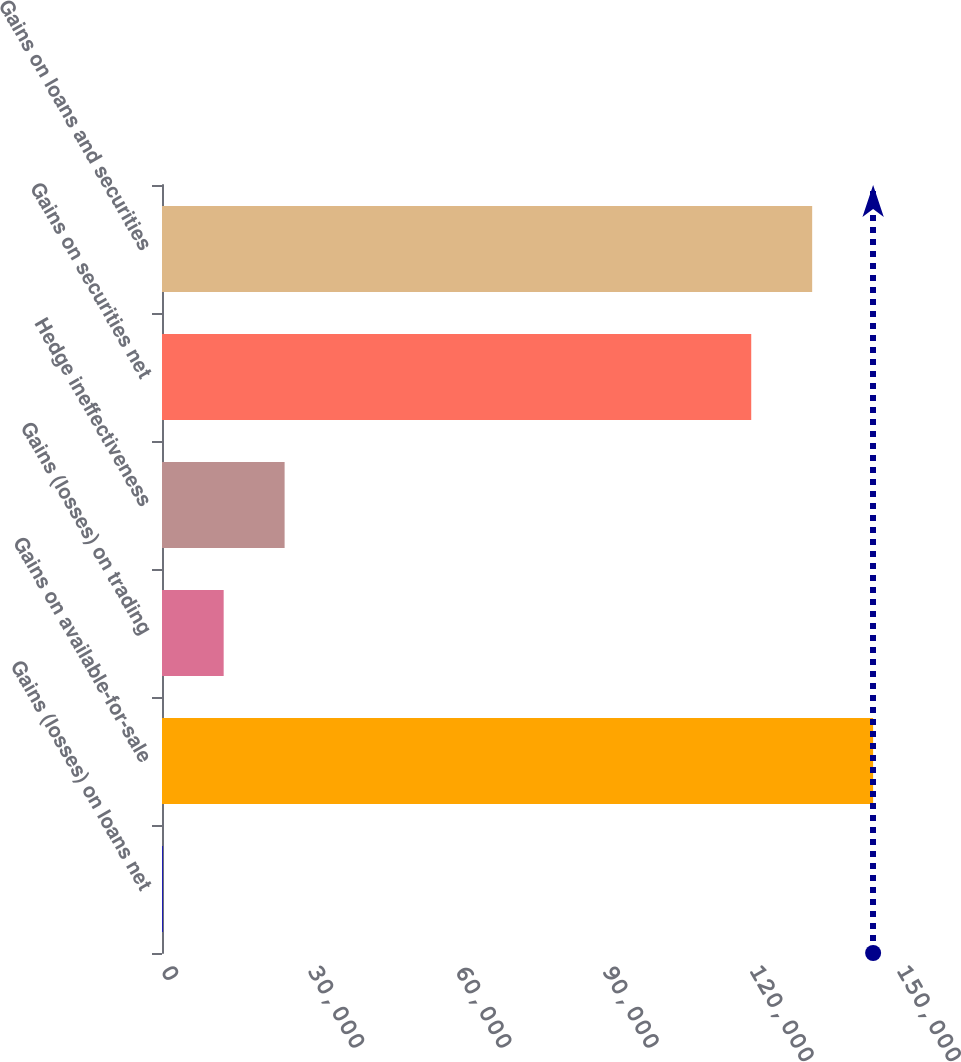Convert chart. <chart><loc_0><loc_0><loc_500><loc_500><bar_chart><fcel>Gains (losses) on loans net<fcel>Gains on available-for-sale<fcel>Gains (losses) on trading<fcel>Hedge ineffectiveness<fcel>Gains on securities net<fcel>Gains on loans and securities<nl><fcel>146<fcel>144930<fcel>12567.4<fcel>24988.8<fcel>120087<fcel>132508<nl></chart> 